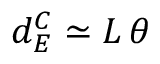Convert formula to latex. <formula><loc_0><loc_0><loc_500><loc_500>d _ { E } ^ { C } \simeq L \, \theta</formula> 